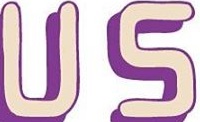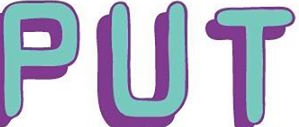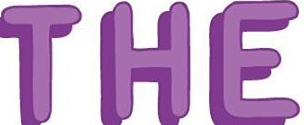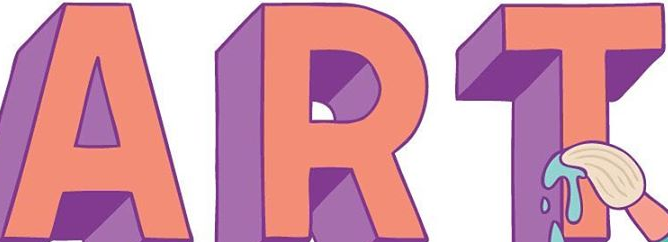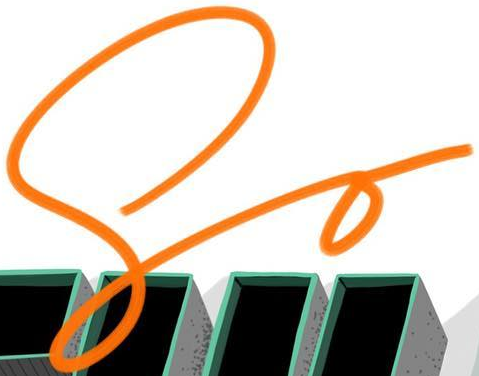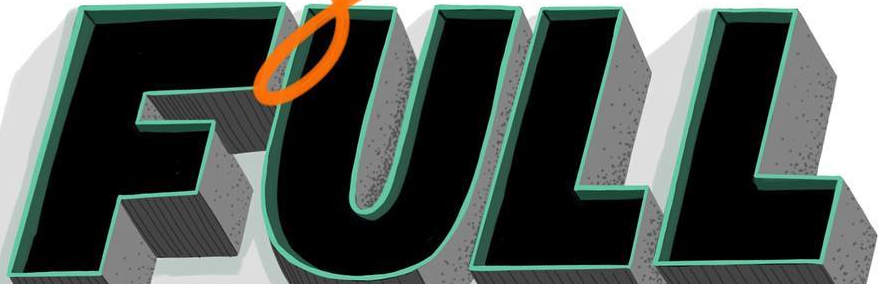Read the text content from these images in order, separated by a semicolon. US; PUT; THE; ART; So; FULL 